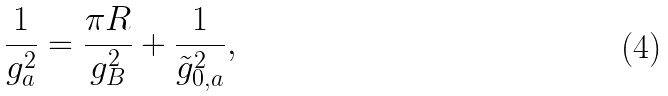Convert formula to latex. <formula><loc_0><loc_0><loc_500><loc_500>\frac { 1 } { g _ { a } ^ { 2 } } = \frac { \pi R } { g _ { B } ^ { 2 } } + \frac { 1 } { \tilde { g } _ { 0 , a } ^ { 2 } } ,</formula> 